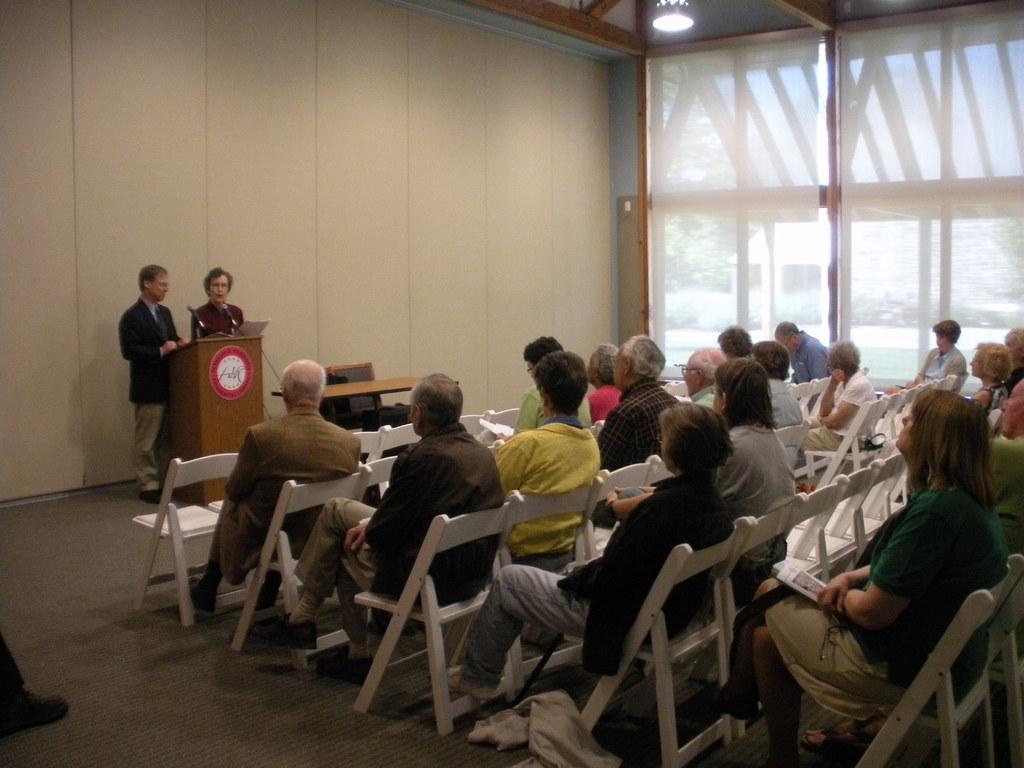In one or two sentences, can you explain what this image depicts? In this picture we can see man and woman standing at podium talking on mic beside to them there is table and chair and in front of them we can see a group of people sitting on chair and listening to them and in background we can see wall, light. 